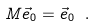Convert formula to latex. <formula><loc_0><loc_0><loc_500><loc_500>M \vec { e } _ { 0 } = \vec { e } _ { 0 } \ .</formula> 